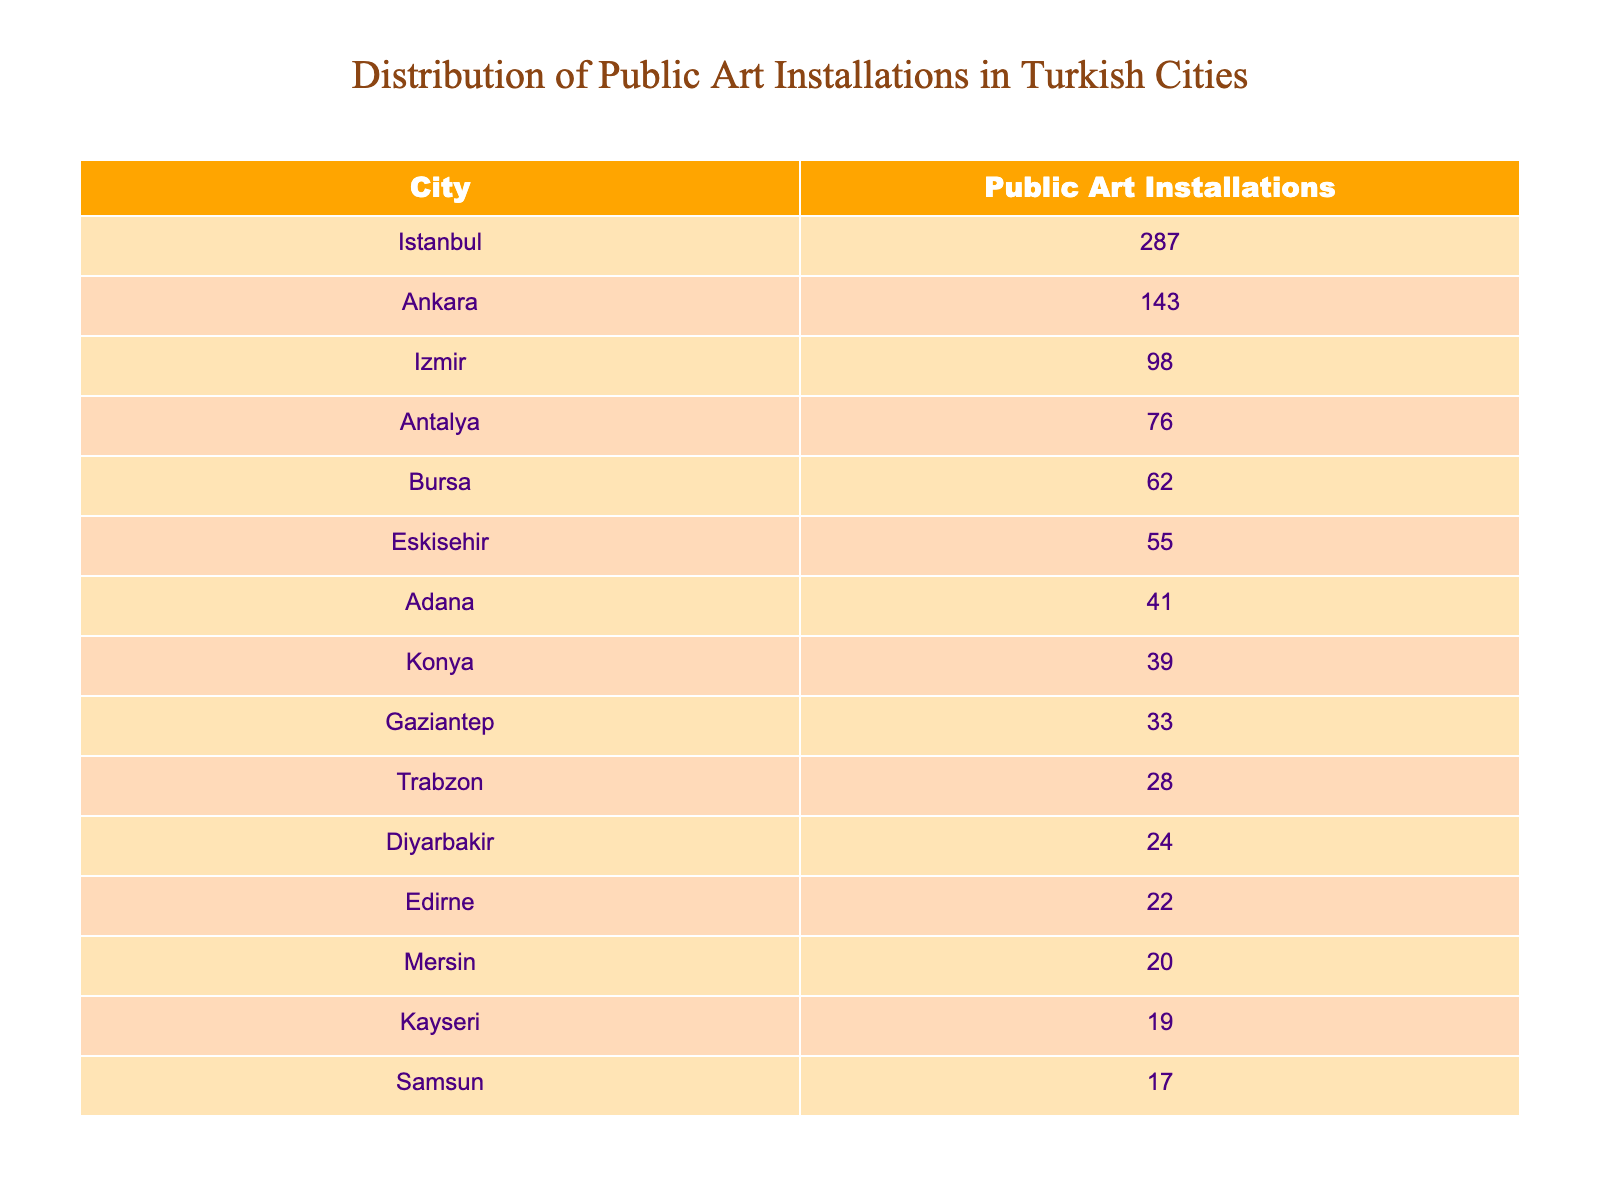What city has the highest number of public art installations? By scanning the table, Istanbul is listed with 287 public art installations, which is higher than any other city in the list.
Answer: Istanbul How many public art installations are there in Ankara? The table lists Ankara as having 143 public art installations.
Answer: 143 What is the total number of public art installations across the ten cities? To find the total, sum the values: 287 + 143 + 98 + 76 + 62 + 55 + 41 + 39 + 33 + 28 + 24 + 22 + 20 + 19 + 17 =  1007
Answer: 1007 Which city has the least public art installations? By reviewing the table, Samsun has the least public art installations listed at 17.
Answer: Samsun How many more public art installations does Istanbul have than Edirne? Istanbul has 287 installations and Edirne has 22, so the difference is 287 - 22 = 265.
Answer: 265 What percentage of the total public art installations does Izmir represent? First, calculate the total installations, which is 1007. Then, Izmir has 98 installations, so the percentage is (98 / 1007) * 100 ≈ 9.73%.
Answer: Approx. 9.73% If we combine the number of installations in Antalya and Bursa, how many would that be? Antalya has 76 installations and Bursa has 62 installations. Adding these gives: 76 + 62 = 138.
Answer: 138 Is the number of public art installations in Diyarbakir greater than 20? Diyarbakir has 24 installations, which is greater than 20, confirming the statement is true.
Answer: Yes Which two cities have a combined total of public art installations greater than 300? Looking at the table, the combination of Istanbul (287) and Ankara (143) gives 287 + 143 = 430, which is over 300.
Answer: Istanbul and Ankara What is the average number of public art installations across all cities listed? To find the average, sum all installations (1007) and divide by the number of cities (15): 1007 / 15 ≈ 67.13.
Answer: Approx. 67.13 